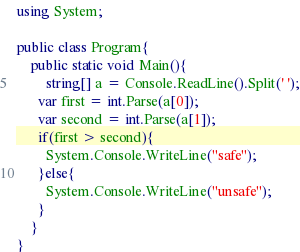<code> <loc_0><loc_0><loc_500><loc_500><_C#_>using System;

public class Program{
    public static void Main(){
        string[] a = Console.ReadLine().Split(' ');
      var first = int.Parse(a[0]);
      var second = int.Parse(a[1]);
      if(first > second){
        System.Console.WriteLine("safe");
      }else{
        System.Console.WriteLine("unsafe");
      }
    }
}


</code> 